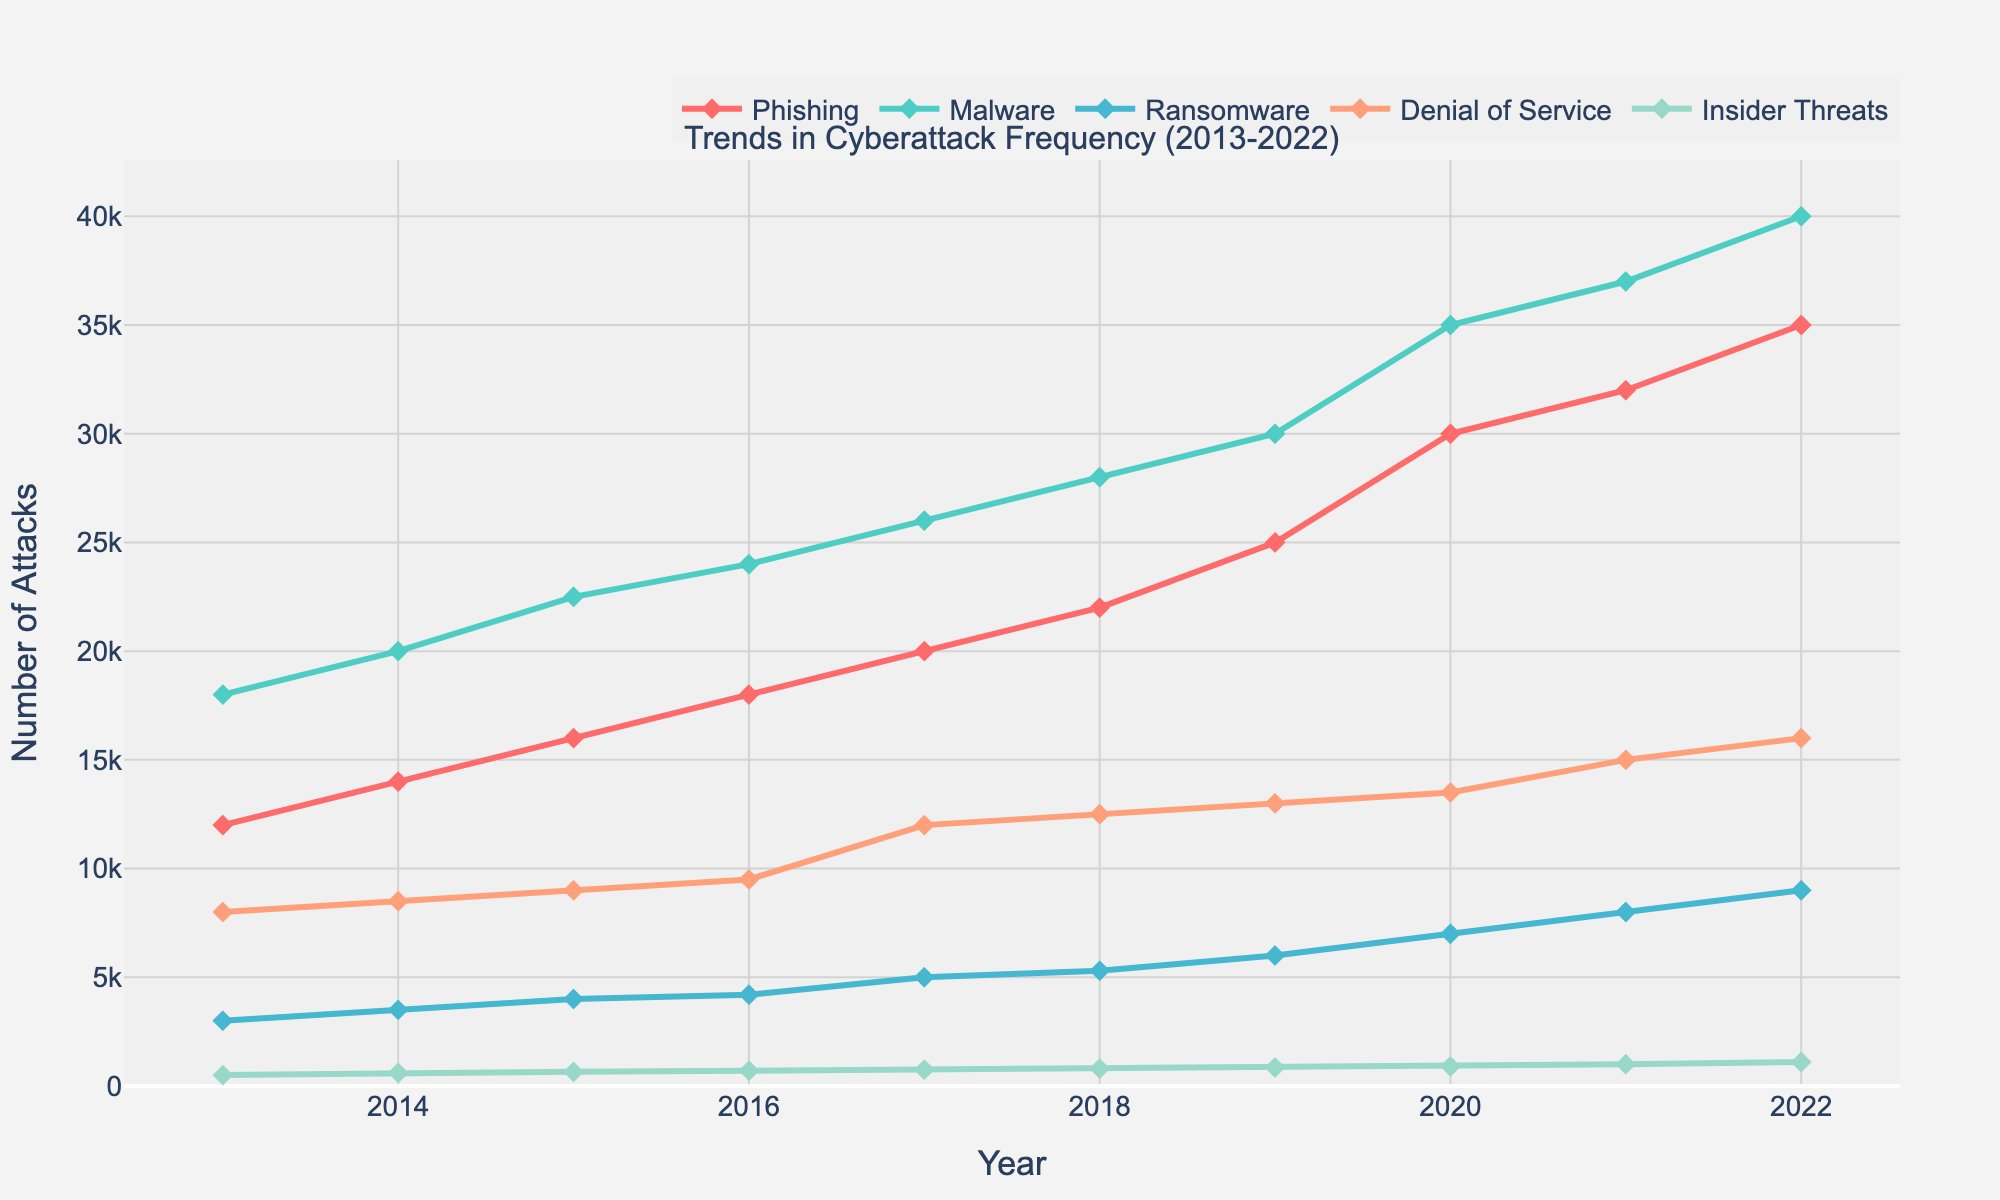What is the title of the plot? The title of the plot is found at the top center and reads "Trends in Cyberattack Frequency (2013-2022)"
Answer: "Trends in Cyberattack Frequency (2013-2022)" How many types of cyberattacks are depicted in the plot? Count the distinct lines representing different attack types in the legend; there are five types
Answer: Five Which year witnessed the highest frequency of Phishing attacks? Look at the Phishing data line (denoted by its color and the legend), and find the highest point on the Y-axis, then correlate with the X-axis (year); 2022 has the highest Y value
Answer: 2022 By how much did the frequency of Ransomware attacks increase from 2013 to 2022? Identify the Y-value for Ransomware at 2013 and 2022; subtract the 2013 value from the 2022 value to find the difference: 9000 - 3000 = 6000
Answer: 6000 Did the frequency of Insider Threats double from 2013 to 2022? Check the Y-values for Insider Threats for both years; compare if 1100 (2022) is at least double of 500 (2013); 1100 > 1000, so yes it doubled
Answer: Yes Which type of attack saw the largest increase in frequency over the decade? Calculate the difference between the 2022 and 2013 values for all attack types; Phishing increased by 23000 (35000-12000), which is the largest increase
Answer: Phishing What is the average annual increase in Malware attacks from 2013 to 2022? Find the total increase from 2013 to 2022 for Malware and divide by the number of years (2022-2013=9); total increase is 40000-18000=22000, so average increase is 22000/9 ≈ 2444.44
Answer: 2444.44 In which year did Denial_of_Service attacks break the 10,000 mark? Identify when the Denial_of_Service line crosses the 10,000 mark on the Y-axis; it reached 12,000 in 2017, exceeding 10,000
Answer: 2017 Between which consecutive years did Insider Threats see the largest increase? Check the differences between consecutive Y-values for Insider Threats; the largest difference is between 2020 and 2021: 100 (1000-900)
Answer: 2020 and 2021 